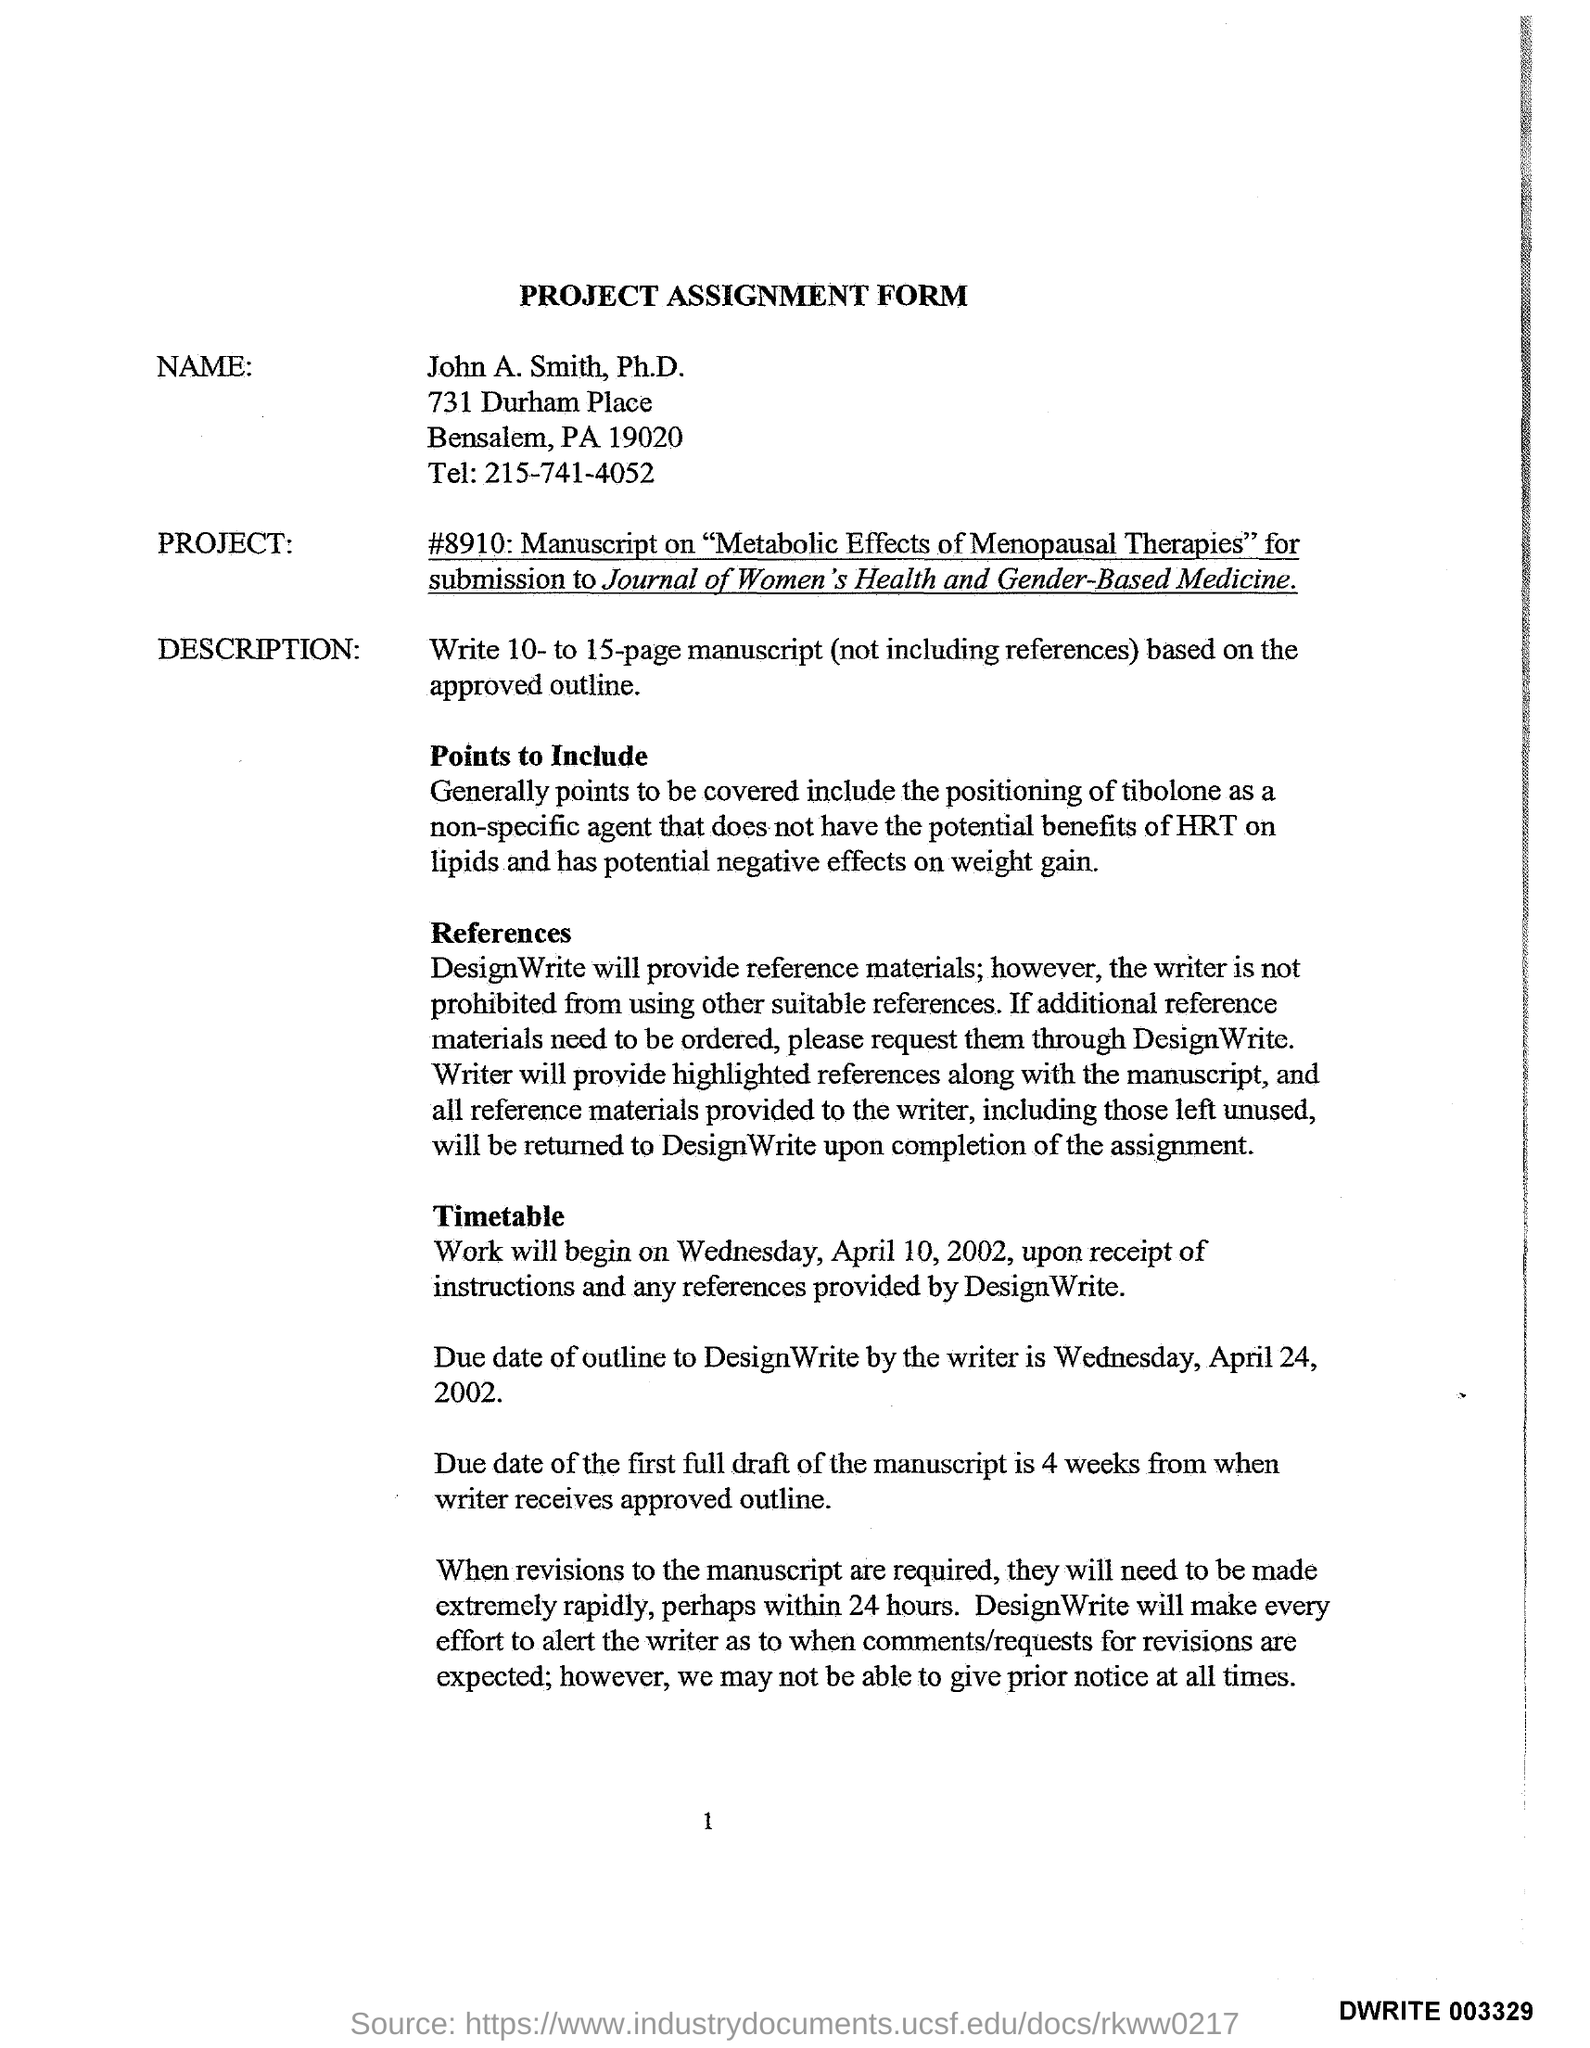What is the headding?
Your response must be concise. PROJECT ASSIGNMENT FORM. What is the name?
Make the answer very short. John A. Smith. 